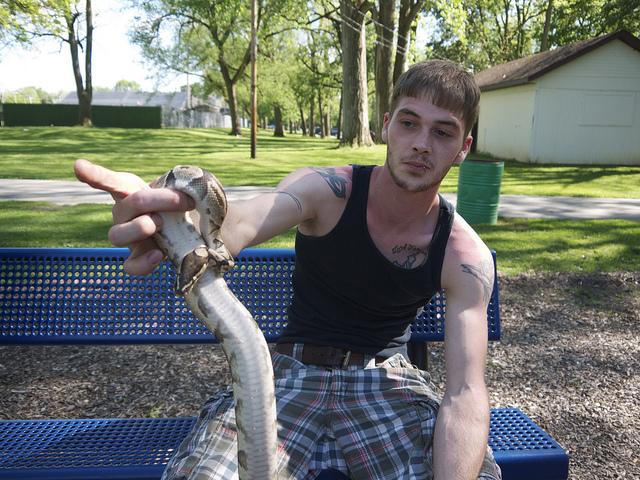Where is the blue bench?
Be succinct. Park. What is the guy holding?
Quick response, please. Snake. Does the guy like the snake?
Answer briefly. Yes. 